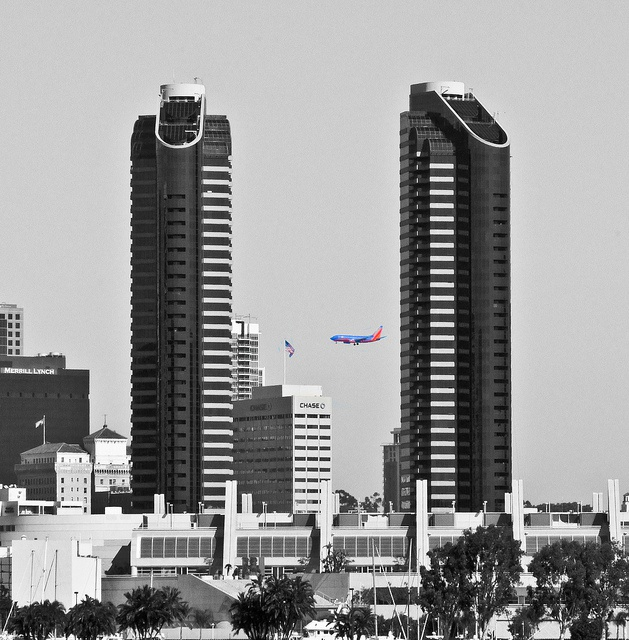Describe the objects in this image and their specific colors. I can see a airplane in lightgray, lightblue, salmon, and lightpink tones in this image. 